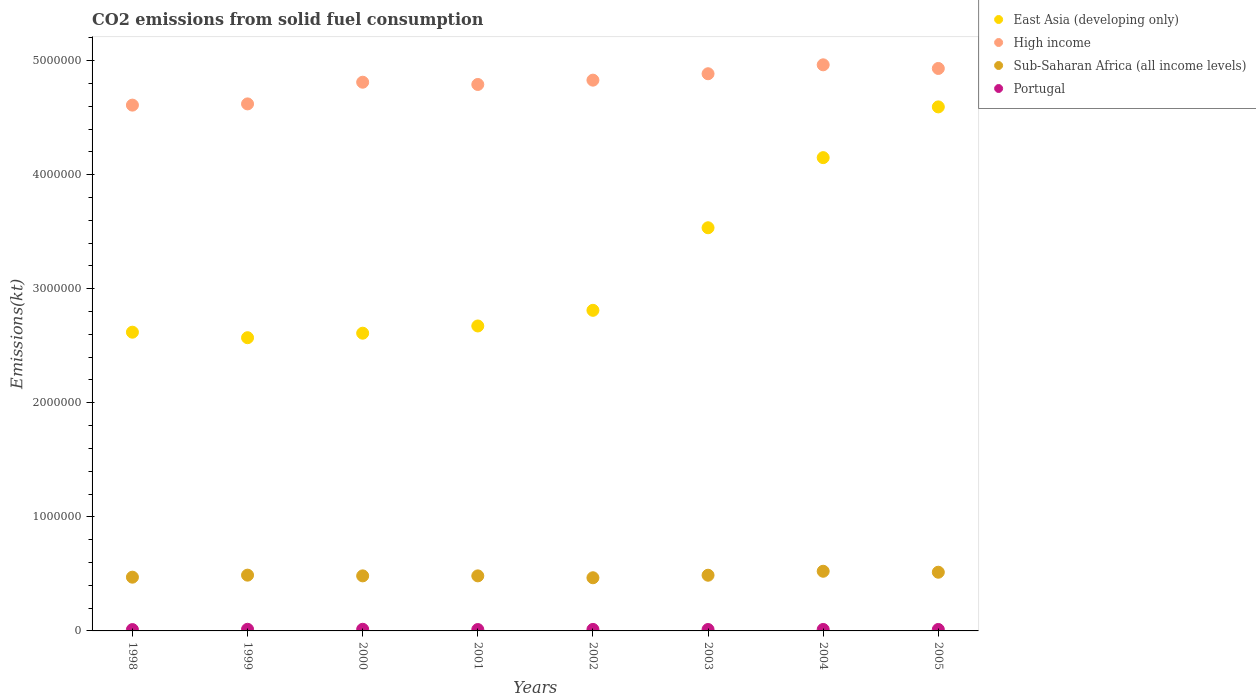How many different coloured dotlines are there?
Your answer should be very brief. 4. What is the amount of CO2 emitted in Portugal in 2005?
Your answer should be very brief. 1.28e+04. Across all years, what is the maximum amount of CO2 emitted in Portugal?
Ensure brevity in your answer.  1.44e+04. Across all years, what is the minimum amount of CO2 emitted in High income?
Your answer should be compact. 4.61e+06. In which year was the amount of CO2 emitted in Sub-Saharan Africa (all income levels) maximum?
Provide a succinct answer. 2004. In which year was the amount of CO2 emitted in Sub-Saharan Africa (all income levels) minimum?
Your answer should be compact. 2002. What is the total amount of CO2 emitted in Portugal in the graph?
Ensure brevity in your answer.  1.04e+05. What is the difference between the amount of CO2 emitted in Portugal in 2000 and that in 2004?
Offer a very short reply. 1477.8. What is the difference between the amount of CO2 emitted in High income in 1999 and the amount of CO2 emitted in East Asia (developing only) in 2000?
Your answer should be very brief. 2.01e+06. What is the average amount of CO2 emitted in East Asia (developing only) per year?
Provide a succinct answer. 3.20e+06. In the year 1998, what is the difference between the amount of CO2 emitted in Portugal and amount of CO2 emitted in Sub-Saharan Africa (all income levels)?
Your answer should be compact. -4.59e+05. What is the ratio of the amount of CO2 emitted in Portugal in 1998 to that in 2004?
Make the answer very short. 0.91. Is the difference between the amount of CO2 emitted in Portugal in 1998 and 2005 greater than the difference between the amount of CO2 emitted in Sub-Saharan Africa (all income levels) in 1998 and 2005?
Your answer should be compact. Yes. What is the difference between the highest and the second highest amount of CO2 emitted in East Asia (developing only)?
Your answer should be compact. 4.45e+05. What is the difference between the highest and the lowest amount of CO2 emitted in East Asia (developing only)?
Your answer should be very brief. 2.02e+06. In how many years, is the amount of CO2 emitted in East Asia (developing only) greater than the average amount of CO2 emitted in East Asia (developing only) taken over all years?
Make the answer very short. 3. Is the sum of the amount of CO2 emitted in East Asia (developing only) in 1998 and 2000 greater than the maximum amount of CO2 emitted in Portugal across all years?
Make the answer very short. Yes. Does the amount of CO2 emitted in Sub-Saharan Africa (all income levels) monotonically increase over the years?
Offer a very short reply. No. How many years are there in the graph?
Ensure brevity in your answer.  8. What is the difference between two consecutive major ticks on the Y-axis?
Keep it short and to the point. 1.00e+06. Does the graph contain grids?
Your answer should be very brief. No. Where does the legend appear in the graph?
Ensure brevity in your answer.  Top right. How are the legend labels stacked?
Your response must be concise. Vertical. What is the title of the graph?
Ensure brevity in your answer.  CO2 emissions from solid fuel consumption. What is the label or title of the X-axis?
Your response must be concise. Years. What is the label or title of the Y-axis?
Make the answer very short. Emissions(kt). What is the Emissions(kt) in East Asia (developing only) in 1998?
Your response must be concise. 2.62e+06. What is the Emissions(kt) in High income in 1998?
Give a very brief answer. 4.61e+06. What is the Emissions(kt) in Sub-Saharan Africa (all income levels) in 1998?
Keep it short and to the point. 4.71e+05. What is the Emissions(kt) of Portugal in 1998?
Offer a very short reply. 1.18e+04. What is the Emissions(kt) of East Asia (developing only) in 1999?
Provide a short and direct response. 2.57e+06. What is the Emissions(kt) in High income in 1999?
Make the answer very short. 4.62e+06. What is the Emissions(kt) of Sub-Saharan Africa (all income levels) in 1999?
Your answer should be very brief. 4.89e+05. What is the Emissions(kt) of Portugal in 1999?
Your answer should be compact. 1.44e+04. What is the Emissions(kt) of East Asia (developing only) in 2000?
Offer a terse response. 2.61e+06. What is the Emissions(kt) of High income in 2000?
Keep it short and to the point. 4.81e+06. What is the Emissions(kt) of Sub-Saharan Africa (all income levels) in 2000?
Provide a succinct answer. 4.83e+05. What is the Emissions(kt) in Portugal in 2000?
Make the answer very short. 1.44e+04. What is the Emissions(kt) in East Asia (developing only) in 2001?
Your answer should be compact. 2.67e+06. What is the Emissions(kt) in High income in 2001?
Ensure brevity in your answer.  4.79e+06. What is the Emissions(kt) of Sub-Saharan Africa (all income levels) in 2001?
Your answer should be compact. 4.83e+05. What is the Emissions(kt) of Portugal in 2001?
Your answer should be very brief. 1.22e+04. What is the Emissions(kt) in East Asia (developing only) in 2002?
Your response must be concise. 2.81e+06. What is the Emissions(kt) in High income in 2002?
Your answer should be very brief. 4.83e+06. What is the Emissions(kt) of Sub-Saharan Africa (all income levels) in 2002?
Keep it short and to the point. 4.66e+05. What is the Emissions(kt) in Portugal in 2002?
Offer a terse response. 1.32e+04. What is the Emissions(kt) in East Asia (developing only) in 2003?
Make the answer very short. 3.53e+06. What is the Emissions(kt) in High income in 2003?
Make the answer very short. 4.88e+06. What is the Emissions(kt) in Sub-Saharan Africa (all income levels) in 2003?
Keep it short and to the point. 4.88e+05. What is the Emissions(kt) in Portugal in 2003?
Provide a short and direct response. 1.24e+04. What is the Emissions(kt) of East Asia (developing only) in 2004?
Give a very brief answer. 4.15e+06. What is the Emissions(kt) of High income in 2004?
Offer a terse response. 4.96e+06. What is the Emissions(kt) in Sub-Saharan Africa (all income levels) in 2004?
Provide a short and direct response. 5.23e+05. What is the Emissions(kt) in Portugal in 2004?
Your answer should be compact. 1.29e+04. What is the Emissions(kt) in East Asia (developing only) in 2005?
Provide a short and direct response. 4.59e+06. What is the Emissions(kt) in High income in 2005?
Keep it short and to the point. 4.93e+06. What is the Emissions(kt) of Sub-Saharan Africa (all income levels) in 2005?
Your response must be concise. 5.15e+05. What is the Emissions(kt) of Portugal in 2005?
Ensure brevity in your answer.  1.28e+04. Across all years, what is the maximum Emissions(kt) in East Asia (developing only)?
Make the answer very short. 4.59e+06. Across all years, what is the maximum Emissions(kt) in High income?
Your response must be concise. 4.96e+06. Across all years, what is the maximum Emissions(kt) of Sub-Saharan Africa (all income levels)?
Provide a short and direct response. 5.23e+05. Across all years, what is the maximum Emissions(kt) in Portugal?
Provide a short and direct response. 1.44e+04. Across all years, what is the minimum Emissions(kt) in East Asia (developing only)?
Provide a succinct answer. 2.57e+06. Across all years, what is the minimum Emissions(kt) of High income?
Give a very brief answer. 4.61e+06. Across all years, what is the minimum Emissions(kt) in Sub-Saharan Africa (all income levels)?
Keep it short and to the point. 4.66e+05. Across all years, what is the minimum Emissions(kt) in Portugal?
Provide a short and direct response. 1.18e+04. What is the total Emissions(kt) of East Asia (developing only) in the graph?
Provide a short and direct response. 2.56e+07. What is the total Emissions(kt) of High income in the graph?
Offer a terse response. 3.84e+07. What is the total Emissions(kt) of Sub-Saharan Africa (all income levels) in the graph?
Keep it short and to the point. 3.92e+06. What is the total Emissions(kt) in Portugal in the graph?
Ensure brevity in your answer.  1.04e+05. What is the difference between the Emissions(kt) in East Asia (developing only) in 1998 and that in 1999?
Your response must be concise. 4.84e+04. What is the difference between the Emissions(kt) of High income in 1998 and that in 1999?
Your response must be concise. -1.08e+04. What is the difference between the Emissions(kt) in Sub-Saharan Africa (all income levels) in 1998 and that in 1999?
Offer a very short reply. -1.78e+04. What is the difference between the Emissions(kt) in Portugal in 1998 and that in 1999?
Your response must be concise. -2603.57. What is the difference between the Emissions(kt) in East Asia (developing only) in 1998 and that in 2000?
Provide a short and direct response. 8834.61. What is the difference between the Emissions(kt) of High income in 1998 and that in 2000?
Provide a succinct answer. -2.01e+05. What is the difference between the Emissions(kt) in Sub-Saharan Africa (all income levels) in 1998 and that in 2000?
Your response must be concise. -1.15e+04. What is the difference between the Emissions(kt) in Portugal in 1998 and that in 2000?
Your answer should be very brief. -2577.9. What is the difference between the Emissions(kt) of East Asia (developing only) in 1998 and that in 2001?
Your answer should be compact. -5.45e+04. What is the difference between the Emissions(kt) of High income in 1998 and that in 2001?
Offer a terse response. -1.81e+05. What is the difference between the Emissions(kt) of Sub-Saharan Africa (all income levels) in 1998 and that in 2001?
Provide a succinct answer. -1.14e+04. What is the difference between the Emissions(kt) of Portugal in 1998 and that in 2001?
Keep it short and to the point. -399.7. What is the difference between the Emissions(kt) in East Asia (developing only) in 1998 and that in 2002?
Offer a very short reply. -1.92e+05. What is the difference between the Emissions(kt) of High income in 1998 and that in 2002?
Provide a short and direct response. -2.19e+05. What is the difference between the Emissions(kt) in Sub-Saharan Africa (all income levels) in 1998 and that in 2002?
Provide a short and direct response. 5099.47. What is the difference between the Emissions(kt) in Portugal in 1998 and that in 2002?
Your answer should be compact. -1397.13. What is the difference between the Emissions(kt) of East Asia (developing only) in 1998 and that in 2003?
Make the answer very short. -9.15e+05. What is the difference between the Emissions(kt) in High income in 1998 and that in 2003?
Your answer should be very brief. -2.75e+05. What is the difference between the Emissions(kt) of Sub-Saharan Africa (all income levels) in 1998 and that in 2003?
Give a very brief answer. -1.71e+04. What is the difference between the Emissions(kt) in Portugal in 1998 and that in 2003?
Offer a terse response. -663.73. What is the difference between the Emissions(kt) in East Asia (developing only) in 1998 and that in 2004?
Offer a terse response. -1.53e+06. What is the difference between the Emissions(kt) in High income in 1998 and that in 2004?
Ensure brevity in your answer.  -3.53e+05. What is the difference between the Emissions(kt) in Sub-Saharan Africa (all income levels) in 1998 and that in 2004?
Give a very brief answer. -5.19e+04. What is the difference between the Emissions(kt) in Portugal in 1998 and that in 2004?
Your answer should be compact. -1100.1. What is the difference between the Emissions(kt) of East Asia (developing only) in 1998 and that in 2005?
Keep it short and to the point. -1.98e+06. What is the difference between the Emissions(kt) in High income in 1998 and that in 2005?
Provide a short and direct response. -3.21e+05. What is the difference between the Emissions(kt) of Sub-Saharan Africa (all income levels) in 1998 and that in 2005?
Keep it short and to the point. -4.34e+04. What is the difference between the Emissions(kt) in Portugal in 1998 and that in 2005?
Ensure brevity in your answer.  -986.42. What is the difference between the Emissions(kt) of East Asia (developing only) in 1999 and that in 2000?
Offer a terse response. -3.96e+04. What is the difference between the Emissions(kt) in High income in 1999 and that in 2000?
Your answer should be very brief. -1.90e+05. What is the difference between the Emissions(kt) in Sub-Saharan Africa (all income levels) in 1999 and that in 2000?
Provide a short and direct response. 6298.44. What is the difference between the Emissions(kt) in Portugal in 1999 and that in 2000?
Offer a terse response. 25.67. What is the difference between the Emissions(kt) in East Asia (developing only) in 1999 and that in 2001?
Give a very brief answer. -1.03e+05. What is the difference between the Emissions(kt) in High income in 1999 and that in 2001?
Give a very brief answer. -1.70e+05. What is the difference between the Emissions(kt) in Sub-Saharan Africa (all income levels) in 1999 and that in 2001?
Provide a short and direct response. 6355.04. What is the difference between the Emissions(kt) in Portugal in 1999 and that in 2001?
Make the answer very short. 2203.87. What is the difference between the Emissions(kt) in East Asia (developing only) in 1999 and that in 2002?
Offer a very short reply. -2.40e+05. What is the difference between the Emissions(kt) in High income in 1999 and that in 2002?
Your answer should be compact. -2.08e+05. What is the difference between the Emissions(kt) in Sub-Saharan Africa (all income levels) in 1999 and that in 2002?
Your answer should be compact. 2.29e+04. What is the difference between the Emissions(kt) of Portugal in 1999 and that in 2002?
Offer a very short reply. 1206.44. What is the difference between the Emissions(kt) of East Asia (developing only) in 1999 and that in 2003?
Your response must be concise. -9.64e+05. What is the difference between the Emissions(kt) in High income in 1999 and that in 2003?
Make the answer very short. -2.64e+05. What is the difference between the Emissions(kt) of Sub-Saharan Africa (all income levels) in 1999 and that in 2003?
Your answer should be compact. 725.29. What is the difference between the Emissions(kt) in Portugal in 1999 and that in 2003?
Keep it short and to the point. 1939.84. What is the difference between the Emissions(kt) in East Asia (developing only) in 1999 and that in 2004?
Your answer should be compact. -1.58e+06. What is the difference between the Emissions(kt) of High income in 1999 and that in 2004?
Keep it short and to the point. -3.43e+05. What is the difference between the Emissions(kt) in Sub-Saharan Africa (all income levels) in 1999 and that in 2004?
Your answer should be very brief. -3.41e+04. What is the difference between the Emissions(kt) of Portugal in 1999 and that in 2004?
Provide a succinct answer. 1503.47. What is the difference between the Emissions(kt) of East Asia (developing only) in 1999 and that in 2005?
Offer a terse response. -2.02e+06. What is the difference between the Emissions(kt) of High income in 1999 and that in 2005?
Your answer should be compact. -3.11e+05. What is the difference between the Emissions(kt) in Sub-Saharan Africa (all income levels) in 1999 and that in 2005?
Give a very brief answer. -2.56e+04. What is the difference between the Emissions(kt) of Portugal in 1999 and that in 2005?
Your answer should be compact. 1617.15. What is the difference between the Emissions(kt) of East Asia (developing only) in 2000 and that in 2001?
Give a very brief answer. -6.34e+04. What is the difference between the Emissions(kt) in High income in 2000 and that in 2001?
Your answer should be compact. 1.97e+04. What is the difference between the Emissions(kt) of Sub-Saharan Africa (all income levels) in 2000 and that in 2001?
Provide a short and direct response. 56.6. What is the difference between the Emissions(kt) in Portugal in 2000 and that in 2001?
Ensure brevity in your answer.  2178.2. What is the difference between the Emissions(kt) in East Asia (developing only) in 2000 and that in 2002?
Your response must be concise. -2.01e+05. What is the difference between the Emissions(kt) of High income in 2000 and that in 2002?
Give a very brief answer. -1.81e+04. What is the difference between the Emissions(kt) of Sub-Saharan Africa (all income levels) in 2000 and that in 2002?
Give a very brief answer. 1.66e+04. What is the difference between the Emissions(kt) in Portugal in 2000 and that in 2002?
Your answer should be compact. 1180.77. What is the difference between the Emissions(kt) of East Asia (developing only) in 2000 and that in 2003?
Provide a succinct answer. -9.24e+05. What is the difference between the Emissions(kt) of High income in 2000 and that in 2003?
Make the answer very short. -7.43e+04. What is the difference between the Emissions(kt) in Sub-Saharan Africa (all income levels) in 2000 and that in 2003?
Make the answer very short. -5573.15. What is the difference between the Emissions(kt) of Portugal in 2000 and that in 2003?
Your response must be concise. 1914.17. What is the difference between the Emissions(kt) of East Asia (developing only) in 2000 and that in 2004?
Make the answer very short. -1.54e+06. What is the difference between the Emissions(kt) of High income in 2000 and that in 2004?
Provide a short and direct response. -1.53e+05. What is the difference between the Emissions(kt) in Sub-Saharan Africa (all income levels) in 2000 and that in 2004?
Provide a short and direct response. -4.04e+04. What is the difference between the Emissions(kt) of Portugal in 2000 and that in 2004?
Your answer should be compact. 1477.8. What is the difference between the Emissions(kt) in East Asia (developing only) in 2000 and that in 2005?
Offer a very short reply. -1.98e+06. What is the difference between the Emissions(kt) of High income in 2000 and that in 2005?
Offer a terse response. -1.21e+05. What is the difference between the Emissions(kt) in Sub-Saharan Africa (all income levels) in 2000 and that in 2005?
Ensure brevity in your answer.  -3.19e+04. What is the difference between the Emissions(kt) of Portugal in 2000 and that in 2005?
Your response must be concise. 1591.48. What is the difference between the Emissions(kt) of East Asia (developing only) in 2001 and that in 2002?
Your response must be concise. -1.37e+05. What is the difference between the Emissions(kt) in High income in 2001 and that in 2002?
Ensure brevity in your answer.  -3.79e+04. What is the difference between the Emissions(kt) of Sub-Saharan Africa (all income levels) in 2001 and that in 2002?
Give a very brief answer. 1.65e+04. What is the difference between the Emissions(kt) in Portugal in 2001 and that in 2002?
Provide a succinct answer. -997.42. What is the difference between the Emissions(kt) in East Asia (developing only) in 2001 and that in 2003?
Offer a terse response. -8.61e+05. What is the difference between the Emissions(kt) in High income in 2001 and that in 2003?
Offer a terse response. -9.40e+04. What is the difference between the Emissions(kt) of Sub-Saharan Africa (all income levels) in 2001 and that in 2003?
Provide a succinct answer. -5629.75. What is the difference between the Emissions(kt) of Portugal in 2001 and that in 2003?
Make the answer very short. -264.02. What is the difference between the Emissions(kt) of East Asia (developing only) in 2001 and that in 2004?
Make the answer very short. -1.48e+06. What is the difference between the Emissions(kt) of High income in 2001 and that in 2004?
Provide a short and direct response. -1.72e+05. What is the difference between the Emissions(kt) in Sub-Saharan Africa (all income levels) in 2001 and that in 2004?
Provide a short and direct response. -4.05e+04. What is the difference between the Emissions(kt) in Portugal in 2001 and that in 2004?
Your response must be concise. -700.4. What is the difference between the Emissions(kt) in East Asia (developing only) in 2001 and that in 2005?
Offer a terse response. -1.92e+06. What is the difference between the Emissions(kt) in High income in 2001 and that in 2005?
Provide a short and direct response. -1.40e+05. What is the difference between the Emissions(kt) of Sub-Saharan Africa (all income levels) in 2001 and that in 2005?
Give a very brief answer. -3.20e+04. What is the difference between the Emissions(kt) in Portugal in 2001 and that in 2005?
Provide a short and direct response. -586.72. What is the difference between the Emissions(kt) in East Asia (developing only) in 2002 and that in 2003?
Provide a succinct answer. -7.24e+05. What is the difference between the Emissions(kt) of High income in 2002 and that in 2003?
Your response must be concise. -5.62e+04. What is the difference between the Emissions(kt) in Sub-Saharan Africa (all income levels) in 2002 and that in 2003?
Your response must be concise. -2.22e+04. What is the difference between the Emissions(kt) in Portugal in 2002 and that in 2003?
Provide a short and direct response. 733.4. What is the difference between the Emissions(kt) in East Asia (developing only) in 2002 and that in 2004?
Make the answer very short. -1.34e+06. What is the difference between the Emissions(kt) in High income in 2002 and that in 2004?
Give a very brief answer. -1.34e+05. What is the difference between the Emissions(kt) in Sub-Saharan Africa (all income levels) in 2002 and that in 2004?
Offer a terse response. -5.70e+04. What is the difference between the Emissions(kt) in Portugal in 2002 and that in 2004?
Ensure brevity in your answer.  297.03. What is the difference between the Emissions(kt) in East Asia (developing only) in 2002 and that in 2005?
Your response must be concise. -1.78e+06. What is the difference between the Emissions(kt) in High income in 2002 and that in 2005?
Offer a terse response. -1.02e+05. What is the difference between the Emissions(kt) in Sub-Saharan Africa (all income levels) in 2002 and that in 2005?
Provide a succinct answer. -4.85e+04. What is the difference between the Emissions(kt) of Portugal in 2002 and that in 2005?
Your answer should be very brief. 410.7. What is the difference between the Emissions(kt) of East Asia (developing only) in 2003 and that in 2004?
Your answer should be compact. -6.15e+05. What is the difference between the Emissions(kt) in High income in 2003 and that in 2004?
Offer a terse response. -7.83e+04. What is the difference between the Emissions(kt) of Sub-Saharan Africa (all income levels) in 2003 and that in 2004?
Provide a succinct answer. -3.48e+04. What is the difference between the Emissions(kt) in Portugal in 2003 and that in 2004?
Your response must be concise. -436.37. What is the difference between the Emissions(kt) in East Asia (developing only) in 2003 and that in 2005?
Offer a very short reply. -1.06e+06. What is the difference between the Emissions(kt) of High income in 2003 and that in 2005?
Keep it short and to the point. -4.63e+04. What is the difference between the Emissions(kt) of Sub-Saharan Africa (all income levels) in 2003 and that in 2005?
Offer a terse response. -2.64e+04. What is the difference between the Emissions(kt) in Portugal in 2003 and that in 2005?
Ensure brevity in your answer.  -322.7. What is the difference between the Emissions(kt) of East Asia (developing only) in 2004 and that in 2005?
Make the answer very short. -4.45e+05. What is the difference between the Emissions(kt) in High income in 2004 and that in 2005?
Your answer should be very brief. 3.20e+04. What is the difference between the Emissions(kt) in Sub-Saharan Africa (all income levels) in 2004 and that in 2005?
Give a very brief answer. 8467.34. What is the difference between the Emissions(kt) in Portugal in 2004 and that in 2005?
Offer a terse response. 113.68. What is the difference between the Emissions(kt) of East Asia (developing only) in 1998 and the Emissions(kt) of High income in 1999?
Make the answer very short. -2.00e+06. What is the difference between the Emissions(kt) in East Asia (developing only) in 1998 and the Emissions(kt) in Sub-Saharan Africa (all income levels) in 1999?
Keep it short and to the point. 2.13e+06. What is the difference between the Emissions(kt) in East Asia (developing only) in 1998 and the Emissions(kt) in Portugal in 1999?
Provide a short and direct response. 2.60e+06. What is the difference between the Emissions(kt) of High income in 1998 and the Emissions(kt) of Sub-Saharan Africa (all income levels) in 1999?
Make the answer very short. 4.12e+06. What is the difference between the Emissions(kt) in High income in 1998 and the Emissions(kt) in Portugal in 1999?
Make the answer very short. 4.60e+06. What is the difference between the Emissions(kt) in Sub-Saharan Africa (all income levels) in 1998 and the Emissions(kt) in Portugal in 1999?
Provide a succinct answer. 4.57e+05. What is the difference between the Emissions(kt) of East Asia (developing only) in 1998 and the Emissions(kt) of High income in 2000?
Your response must be concise. -2.19e+06. What is the difference between the Emissions(kt) in East Asia (developing only) in 1998 and the Emissions(kt) in Sub-Saharan Africa (all income levels) in 2000?
Offer a very short reply. 2.14e+06. What is the difference between the Emissions(kt) in East Asia (developing only) in 1998 and the Emissions(kt) in Portugal in 2000?
Offer a terse response. 2.60e+06. What is the difference between the Emissions(kt) of High income in 1998 and the Emissions(kt) of Sub-Saharan Africa (all income levels) in 2000?
Your answer should be compact. 4.13e+06. What is the difference between the Emissions(kt) in High income in 1998 and the Emissions(kt) in Portugal in 2000?
Make the answer very short. 4.60e+06. What is the difference between the Emissions(kt) in Sub-Saharan Africa (all income levels) in 1998 and the Emissions(kt) in Portugal in 2000?
Make the answer very short. 4.57e+05. What is the difference between the Emissions(kt) of East Asia (developing only) in 1998 and the Emissions(kt) of High income in 2001?
Make the answer very short. -2.17e+06. What is the difference between the Emissions(kt) in East Asia (developing only) in 1998 and the Emissions(kt) in Sub-Saharan Africa (all income levels) in 2001?
Your response must be concise. 2.14e+06. What is the difference between the Emissions(kt) in East Asia (developing only) in 1998 and the Emissions(kt) in Portugal in 2001?
Offer a very short reply. 2.61e+06. What is the difference between the Emissions(kt) of High income in 1998 and the Emissions(kt) of Sub-Saharan Africa (all income levels) in 2001?
Your response must be concise. 4.13e+06. What is the difference between the Emissions(kt) in High income in 1998 and the Emissions(kt) in Portugal in 2001?
Provide a short and direct response. 4.60e+06. What is the difference between the Emissions(kt) of Sub-Saharan Africa (all income levels) in 1998 and the Emissions(kt) of Portugal in 2001?
Provide a succinct answer. 4.59e+05. What is the difference between the Emissions(kt) in East Asia (developing only) in 1998 and the Emissions(kt) in High income in 2002?
Provide a short and direct response. -2.21e+06. What is the difference between the Emissions(kt) in East Asia (developing only) in 1998 and the Emissions(kt) in Sub-Saharan Africa (all income levels) in 2002?
Provide a short and direct response. 2.15e+06. What is the difference between the Emissions(kt) in East Asia (developing only) in 1998 and the Emissions(kt) in Portugal in 2002?
Offer a very short reply. 2.61e+06. What is the difference between the Emissions(kt) of High income in 1998 and the Emissions(kt) of Sub-Saharan Africa (all income levels) in 2002?
Provide a short and direct response. 4.14e+06. What is the difference between the Emissions(kt) of High income in 1998 and the Emissions(kt) of Portugal in 2002?
Your answer should be compact. 4.60e+06. What is the difference between the Emissions(kt) of Sub-Saharan Africa (all income levels) in 1998 and the Emissions(kt) of Portugal in 2002?
Provide a succinct answer. 4.58e+05. What is the difference between the Emissions(kt) in East Asia (developing only) in 1998 and the Emissions(kt) in High income in 2003?
Your answer should be very brief. -2.27e+06. What is the difference between the Emissions(kt) in East Asia (developing only) in 1998 and the Emissions(kt) in Sub-Saharan Africa (all income levels) in 2003?
Give a very brief answer. 2.13e+06. What is the difference between the Emissions(kt) of East Asia (developing only) in 1998 and the Emissions(kt) of Portugal in 2003?
Your answer should be compact. 2.61e+06. What is the difference between the Emissions(kt) in High income in 1998 and the Emissions(kt) in Sub-Saharan Africa (all income levels) in 2003?
Your answer should be very brief. 4.12e+06. What is the difference between the Emissions(kt) of High income in 1998 and the Emissions(kt) of Portugal in 2003?
Make the answer very short. 4.60e+06. What is the difference between the Emissions(kt) of Sub-Saharan Africa (all income levels) in 1998 and the Emissions(kt) of Portugal in 2003?
Give a very brief answer. 4.59e+05. What is the difference between the Emissions(kt) in East Asia (developing only) in 1998 and the Emissions(kt) in High income in 2004?
Provide a short and direct response. -2.34e+06. What is the difference between the Emissions(kt) in East Asia (developing only) in 1998 and the Emissions(kt) in Sub-Saharan Africa (all income levels) in 2004?
Provide a short and direct response. 2.10e+06. What is the difference between the Emissions(kt) of East Asia (developing only) in 1998 and the Emissions(kt) of Portugal in 2004?
Make the answer very short. 2.61e+06. What is the difference between the Emissions(kt) in High income in 1998 and the Emissions(kt) in Sub-Saharan Africa (all income levels) in 2004?
Make the answer very short. 4.09e+06. What is the difference between the Emissions(kt) in High income in 1998 and the Emissions(kt) in Portugal in 2004?
Give a very brief answer. 4.60e+06. What is the difference between the Emissions(kt) of Sub-Saharan Africa (all income levels) in 1998 and the Emissions(kt) of Portugal in 2004?
Your response must be concise. 4.58e+05. What is the difference between the Emissions(kt) in East Asia (developing only) in 1998 and the Emissions(kt) in High income in 2005?
Keep it short and to the point. -2.31e+06. What is the difference between the Emissions(kt) in East Asia (developing only) in 1998 and the Emissions(kt) in Sub-Saharan Africa (all income levels) in 2005?
Your answer should be compact. 2.10e+06. What is the difference between the Emissions(kt) of East Asia (developing only) in 1998 and the Emissions(kt) of Portugal in 2005?
Give a very brief answer. 2.61e+06. What is the difference between the Emissions(kt) of High income in 1998 and the Emissions(kt) of Sub-Saharan Africa (all income levels) in 2005?
Offer a terse response. 4.09e+06. What is the difference between the Emissions(kt) of High income in 1998 and the Emissions(kt) of Portugal in 2005?
Give a very brief answer. 4.60e+06. What is the difference between the Emissions(kt) in Sub-Saharan Africa (all income levels) in 1998 and the Emissions(kt) in Portugal in 2005?
Your response must be concise. 4.58e+05. What is the difference between the Emissions(kt) in East Asia (developing only) in 1999 and the Emissions(kt) in High income in 2000?
Your answer should be very brief. -2.24e+06. What is the difference between the Emissions(kt) in East Asia (developing only) in 1999 and the Emissions(kt) in Sub-Saharan Africa (all income levels) in 2000?
Your response must be concise. 2.09e+06. What is the difference between the Emissions(kt) in East Asia (developing only) in 1999 and the Emissions(kt) in Portugal in 2000?
Give a very brief answer. 2.56e+06. What is the difference between the Emissions(kt) of High income in 1999 and the Emissions(kt) of Sub-Saharan Africa (all income levels) in 2000?
Offer a very short reply. 4.14e+06. What is the difference between the Emissions(kt) of High income in 1999 and the Emissions(kt) of Portugal in 2000?
Give a very brief answer. 4.61e+06. What is the difference between the Emissions(kt) in Sub-Saharan Africa (all income levels) in 1999 and the Emissions(kt) in Portugal in 2000?
Ensure brevity in your answer.  4.75e+05. What is the difference between the Emissions(kt) of East Asia (developing only) in 1999 and the Emissions(kt) of High income in 2001?
Your response must be concise. -2.22e+06. What is the difference between the Emissions(kt) in East Asia (developing only) in 1999 and the Emissions(kt) in Sub-Saharan Africa (all income levels) in 2001?
Offer a very short reply. 2.09e+06. What is the difference between the Emissions(kt) of East Asia (developing only) in 1999 and the Emissions(kt) of Portugal in 2001?
Make the answer very short. 2.56e+06. What is the difference between the Emissions(kt) in High income in 1999 and the Emissions(kt) in Sub-Saharan Africa (all income levels) in 2001?
Your response must be concise. 4.14e+06. What is the difference between the Emissions(kt) in High income in 1999 and the Emissions(kt) in Portugal in 2001?
Keep it short and to the point. 4.61e+06. What is the difference between the Emissions(kt) in Sub-Saharan Africa (all income levels) in 1999 and the Emissions(kt) in Portugal in 2001?
Offer a terse response. 4.77e+05. What is the difference between the Emissions(kt) of East Asia (developing only) in 1999 and the Emissions(kt) of High income in 2002?
Provide a short and direct response. -2.26e+06. What is the difference between the Emissions(kt) in East Asia (developing only) in 1999 and the Emissions(kt) in Sub-Saharan Africa (all income levels) in 2002?
Your answer should be very brief. 2.10e+06. What is the difference between the Emissions(kt) of East Asia (developing only) in 1999 and the Emissions(kt) of Portugal in 2002?
Offer a very short reply. 2.56e+06. What is the difference between the Emissions(kt) of High income in 1999 and the Emissions(kt) of Sub-Saharan Africa (all income levels) in 2002?
Keep it short and to the point. 4.15e+06. What is the difference between the Emissions(kt) of High income in 1999 and the Emissions(kt) of Portugal in 2002?
Provide a succinct answer. 4.61e+06. What is the difference between the Emissions(kt) in Sub-Saharan Africa (all income levels) in 1999 and the Emissions(kt) in Portugal in 2002?
Ensure brevity in your answer.  4.76e+05. What is the difference between the Emissions(kt) in East Asia (developing only) in 1999 and the Emissions(kt) in High income in 2003?
Make the answer very short. -2.31e+06. What is the difference between the Emissions(kt) in East Asia (developing only) in 1999 and the Emissions(kt) in Sub-Saharan Africa (all income levels) in 2003?
Your answer should be compact. 2.08e+06. What is the difference between the Emissions(kt) in East Asia (developing only) in 1999 and the Emissions(kt) in Portugal in 2003?
Offer a terse response. 2.56e+06. What is the difference between the Emissions(kt) of High income in 1999 and the Emissions(kt) of Sub-Saharan Africa (all income levels) in 2003?
Your answer should be compact. 4.13e+06. What is the difference between the Emissions(kt) in High income in 1999 and the Emissions(kt) in Portugal in 2003?
Provide a short and direct response. 4.61e+06. What is the difference between the Emissions(kt) of Sub-Saharan Africa (all income levels) in 1999 and the Emissions(kt) of Portugal in 2003?
Provide a short and direct response. 4.77e+05. What is the difference between the Emissions(kt) in East Asia (developing only) in 1999 and the Emissions(kt) in High income in 2004?
Provide a succinct answer. -2.39e+06. What is the difference between the Emissions(kt) in East Asia (developing only) in 1999 and the Emissions(kt) in Sub-Saharan Africa (all income levels) in 2004?
Your answer should be compact. 2.05e+06. What is the difference between the Emissions(kt) of East Asia (developing only) in 1999 and the Emissions(kt) of Portugal in 2004?
Give a very brief answer. 2.56e+06. What is the difference between the Emissions(kt) in High income in 1999 and the Emissions(kt) in Sub-Saharan Africa (all income levels) in 2004?
Keep it short and to the point. 4.10e+06. What is the difference between the Emissions(kt) in High income in 1999 and the Emissions(kt) in Portugal in 2004?
Your answer should be compact. 4.61e+06. What is the difference between the Emissions(kt) of Sub-Saharan Africa (all income levels) in 1999 and the Emissions(kt) of Portugal in 2004?
Provide a short and direct response. 4.76e+05. What is the difference between the Emissions(kt) in East Asia (developing only) in 1999 and the Emissions(kt) in High income in 2005?
Provide a short and direct response. -2.36e+06. What is the difference between the Emissions(kt) of East Asia (developing only) in 1999 and the Emissions(kt) of Sub-Saharan Africa (all income levels) in 2005?
Offer a terse response. 2.06e+06. What is the difference between the Emissions(kt) of East Asia (developing only) in 1999 and the Emissions(kt) of Portugal in 2005?
Your response must be concise. 2.56e+06. What is the difference between the Emissions(kt) of High income in 1999 and the Emissions(kt) of Sub-Saharan Africa (all income levels) in 2005?
Your response must be concise. 4.11e+06. What is the difference between the Emissions(kt) of High income in 1999 and the Emissions(kt) of Portugal in 2005?
Your answer should be compact. 4.61e+06. What is the difference between the Emissions(kt) in Sub-Saharan Africa (all income levels) in 1999 and the Emissions(kt) in Portugal in 2005?
Ensure brevity in your answer.  4.76e+05. What is the difference between the Emissions(kt) of East Asia (developing only) in 2000 and the Emissions(kt) of High income in 2001?
Keep it short and to the point. -2.18e+06. What is the difference between the Emissions(kt) of East Asia (developing only) in 2000 and the Emissions(kt) of Sub-Saharan Africa (all income levels) in 2001?
Offer a terse response. 2.13e+06. What is the difference between the Emissions(kt) of East Asia (developing only) in 2000 and the Emissions(kt) of Portugal in 2001?
Ensure brevity in your answer.  2.60e+06. What is the difference between the Emissions(kt) of High income in 2000 and the Emissions(kt) of Sub-Saharan Africa (all income levels) in 2001?
Offer a terse response. 4.33e+06. What is the difference between the Emissions(kt) in High income in 2000 and the Emissions(kt) in Portugal in 2001?
Keep it short and to the point. 4.80e+06. What is the difference between the Emissions(kt) of Sub-Saharan Africa (all income levels) in 2000 and the Emissions(kt) of Portugal in 2001?
Your answer should be very brief. 4.70e+05. What is the difference between the Emissions(kt) of East Asia (developing only) in 2000 and the Emissions(kt) of High income in 2002?
Provide a succinct answer. -2.22e+06. What is the difference between the Emissions(kt) of East Asia (developing only) in 2000 and the Emissions(kt) of Sub-Saharan Africa (all income levels) in 2002?
Offer a terse response. 2.14e+06. What is the difference between the Emissions(kt) in East Asia (developing only) in 2000 and the Emissions(kt) in Portugal in 2002?
Offer a terse response. 2.60e+06. What is the difference between the Emissions(kt) of High income in 2000 and the Emissions(kt) of Sub-Saharan Africa (all income levels) in 2002?
Provide a succinct answer. 4.34e+06. What is the difference between the Emissions(kt) of High income in 2000 and the Emissions(kt) of Portugal in 2002?
Keep it short and to the point. 4.80e+06. What is the difference between the Emissions(kt) in Sub-Saharan Africa (all income levels) in 2000 and the Emissions(kt) in Portugal in 2002?
Offer a very short reply. 4.69e+05. What is the difference between the Emissions(kt) in East Asia (developing only) in 2000 and the Emissions(kt) in High income in 2003?
Make the answer very short. -2.27e+06. What is the difference between the Emissions(kt) of East Asia (developing only) in 2000 and the Emissions(kt) of Sub-Saharan Africa (all income levels) in 2003?
Keep it short and to the point. 2.12e+06. What is the difference between the Emissions(kt) in East Asia (developing only) in 2000 and the Emissions(kt) in Portugal in 2003?
Make the answer very short. 2.60e+06. What is the difference between the Emissions(kt) of High income in 2000 and the Emissions(kt) of Sub-Saharan Africa (all income levels) in 2003?
Give a very brief answer. 4.32e+06. What is the difference between the Emissions(kt) of High income in 2000 and the Emissions(kt) of Portugal in 2003?
Provide a succinct answer. 4.80e+06. What is the difference between the Emissions(kt) of Sub-Saharan Africa (all income levels) in 2000 and the Emissions(kt) of Portugal in 2003?
Offer a very short reply. 4.70e+05. What is the difference between the Emissions(kt) in East Asia (developing only) in 2000 and the Emissions(kt) in High income in 2004?
Keep it short and to the point. -2.35e+06. What is the difference between the Emissions(kt) of East Asia (developing only) in 2000 and the Emissions(kt) of Sub-Saharan Africa (all income levels) in 2004?
Make the answer very short. 2.09e+06. What is the difference between the Emissions(kt) of East Asia (developing only) in 2000 and the Emissions(kt) of Portugal in 2004?
Ensure brevity in your answer.  2.60e+06. What is the difference between the Emissions(kt) of High income in 2000 and the Emissions(kt) of Sub-Saharan Africa (all income levels) in 2004?
Keep it short and to the point. 4.29e+06. What is the difference between the Emissions(kt) of High income in 2000 and the Emissions(kt) of Portugal in 2004?
Keep it short and to the point. 4.80e+06. What is the difference between the Emissions(kt) of Sub-Saharan Africa (all income levels) in 2000 and the Emissions(kt) of Portugal in 2004?
Provide a succinct answer. 4.70e+05. What is the difference between the Emissions(kt) in East Asia (developing only) in 2000 and the Emissions(kt) in High income in 2005?
Offer a very short reply. -2.32e+06. What is the difference between the Emissions(kt) in East Asia (developing only) in 2000 and the Emissions(kt) in Sub-Saharan Africa (all income levels) in 2005?
Your answer should be very brief. 2.10e+06. What is the difference between the Emissions(kt) of East Asia (developing only) in 2000 and the Emissions(kt) of Portugal in 2005?
Give a very brief answer. 2.60e+06. What is the difference between the Emissions(kt) of High income in 2000 and the Emissions(kt) of Sub-Saharan Africa (all income levels) in 2005?
Make the answer very short. 4.30e+06. What is the difference between the Emissions(kt) in High income in 2000 and the Emissions(kt) in Portugal in 2005?
Ensure brevity in your answer.  4.80e+06. What is the difference between the Emissions(kt) of Sub-Saharan Africa (all income levels) in 2000 and the Emissions(kt) of Portugal in 2005?
Provide a succinct answer. 4.70e+05. What is the difference between the Emissions(kt) of East Asia (developing only) in 2001 and the Emissions(kt) of High income in 2002?
Give a very brief answer. -2.15e+06. What is the difference between the Emissions(kt) in East Asia (developing only) in 2001 and the Emissions(kt) in Sub-Saharan Africa (all income levels) in 2002?
Make the answer very short. 2.21e+06. What is the difference between the Emissions(kt) in East Asia (developing only) in 2001 and the Emissions(kt) in Portugal in 2002?
Your response must be concise. 2.66e+06. What is the difference between the Emissions(kt) in High income in 2001 and the Emissions(kt) in Sub-Saharan Africa (all income levels) in 2002?
Ensure brevity in your answer.  4.32e+06. What is the difference between the Emissions(kt) in High income in 2001 and the Emissions(kt) in Portugal in 2002?
Provide a succinct answer. 4.78e+06. What is the difference between the Emissions(kt) of Sub-Saharan Africa (all income levels) in 2001 and the Emissions(kt) of Portugal in 2002?
Your answer should be very brief. 4.69e+05. What is the difference between the Emissions(kt) of East Asia (developing only) in 2001 and the Emissions(kt) of High income in 2003?
Ensure brevity in your answer.  -2.21e+06. What is the difference between the Emissions(kt) in East Asia (developing only) in 2001 and the Emissions(kt) in Sub-Saharan Africa (all income levels) in 2003?
Ensure brevity in your answer.  2.19e+06. What is the difference between the Emissions(kt) in East Asia (developing only) in 2001 and the Emissions(kt) in Portugal in 2003?
Your answer should be compact. 2.66e+06. What is the difference between the Emissions(kt) in High income in 2001 and the Emissions(kt) in Sub-Saharan Africa (all income levels) in 2003?
Give a very brief answer. 4.30e+06. What is the difference between the Emissions(kt) of High income in 2001 and the Emissions(kt) of Portugal in 2003?
Ensure brevity in your answer.  4.78e+06. What is the difference between the Emissions(kt) in Sub-Saharan Africa (all income levels) in 2001 and the Emissions(kt) in Portugal in 2003?
Your answer should be compact. 4.70e+05. What is the difference between the Emissions(kt) of East Asia (developing only) in 2001 and the Emissions(kt) of High income in 2004?
Your answer should be very brief. -2.29e+06. What is the difference between the Emissions(kt) in East Asia (developing only) in 2001 and the Emissions(kt) in Sub-Saharan Africa (all income levels) in 2004?
Ensure brevity in your answer.  2.15e+06. What is the difference between the Emissions(kt) of East Asia (developing only) in 2001 and the Emissions(kt) of Portugal in 2004?
Provide a short and direct response. 2.66e+06. What is the difference between the Emissions(kt) in High income in 2001 and the Emissions(kt) in Sub-Saharan Africa (all income levels) in 2004?
Your answer should be very brief. 4.27e+06. What is the difference between the Emissions(kt) in High income in 2001 and the Emissions(kt) in Portugal in 2004?
Give a very brief answer. 4.78e+06. What is the difference between the Emissions(kt) in Sub-Saharan Africa (all income levels) in 2001 and the Emissions(kt) in Portugal in 2004?
Your answer should be very brief. 4.70e+05. What is the difference between the Emissions(kt) of East Asia (developing only) in 2001 and the Emissions(kt) of High income in 2005?
Offer a terse response. -2.26e+06. What is the difference between the Emissions(kt) in East Asia (developing only) in 2001 and the Emissions(kt) in Sub-Saharan Africa (all income levels) in 2005?
Offer a very short reply. 2.16e+06. What is the difference between the Emissions(kt) of East Asia (developing only) in 2001 and the Emissions(kt) of Portugal in 2005?
Keep it short and to the point. 2.66e+06. What is the difference between the Emissions(kt) in High income in 2001 and the Emissions(kt) in Sub-Saharan Africa (all income levels) in 2005?
Keep it short and to the point. 4.28e+06. What is the difference between the Emissions(kt) in High income in 2001 and the Emissions(kt) in Portugal in 2005?
Your response must be concise. 4.78e+06. What is the difference between the Emissions(kt) in Sub-Saharan Africa (all income levels) in 2001 and the Emissions(kt) in Portugal in 2005?
Provide a short and direct response. 4.70e+05. What is the difference between the Emissions(kt) of East Asia (developing only) in 2002 and the Emissions(kt) of High income in 2003?
Ensure brevity in your answer.  -2.07e+06. What is the difference between the Emissions(kt) in East Asia (developing only) in 2002 and the Emissions(kt) in Sub-Saharan Africa (all income levels) in 2003?
Offer a terse response. 2.32e+06. What is the difference between the Emissions(kt) in East Asia (developing only) in 2002 and the Emissions(kt) in Portugal in 2003?
Provide a short and direct response. 2.80e+06. What is the difference between the Emissions(kt) in High income in 2002 and the Emissions(kt) in Sub-Saharan Africa (all income levels) in 2003?
Ensure brevity in your answer.  4.34e+06. What is the difference between the Emissions(kt) in High income in 2002 and the Emissions(kt) in Portugal in 2003?
Your response must be concise. 4.82e+06. What is the difference between the Emissions(kt) of Sub-Saharan Africa (all income levels) in 2002 and the Emissions(kt) of Portugal in 2003?
Your answer should be compact. 4.54e+05. What is the difference between the Emissions(kt) of East Asia (developing only) in 2002 and the Emissions(kt) of High income in 2004?
Offer a terse response. -2.15e+06. What is the difference between the Emissions(kt) of East Asia (developing only) in 2002 and the Emissions(kt) of Sub-Saharan Africa (all income levels) in 2004?
Your response must be concise. 2.29e+06. What is the difference between the Emissions(kt) of East Asia (developing only) in 2002 and the Emissions(kt) of Portugal in 2004?
Your answer should be compact. 2.80e+06. What is the difference between the Emissions(kt) in High income in 2002 and the Emissions(kt) in Sub-Saharan Africa (all income levels) in 2004?
Provide a succinct answer. 4.31e+06. What is the difference between the Emissions(kt) in High income in 2002 and the Emissions(kt) in Portugal in 2004?
Your answer should be compact. 4.82e+06. What is the difference between the Emissions(kt) of Sub-Saharan Africa (all income levels) in 2002 and the Emissions(kt) of Portugal in 2004?
Your response must be concise. 4.53e+05. What is the difference between the Emissions(kt) of East Asia (developing only) in 2002 and the Emissions(kt) of High income in 2005?
Make the answer very short. -2.12e+06. What is the difference between the Emissions(kt) of East Asia (developing only) in 2002 and the Emissions(kt) of Sub-Saharan Africa (all income levels) in 2005?
Your answer should be very brief. 2.30e+06. What is the difference between the Emissions(kt) in East Asia (developing only) in 2002 and the Emissions(kt) in Portugal in 2005?
Make the answer very short. 2.80e+06. What is the difference between the Emissions(kt) of High income in 2002 and the Emissions(kt) of Sub-Saharan Africa (all income levels) in 2005?
Ensure brevity in your answer.  4.31e+06. What is the difference between the Emissions(kt) in High income in 2002 and the Emissions(kt) in Portugal in 2005?
Your response must be concise. 4.82e+06. What is the difference between the Emissions(kt) in Sub-Saharan Africa (all income levels) in 2002 and the Emissions(kt) in Portugal in 2005?
Make the answer very short. 4.53e+05. What is the difference between the Emissions(kt) in East Asia (developing only) in 2003 and the Emissions(kt) in High income in 2004?
Your answer should be very brief. -1.43e+06. What is the difference between the Emissions(kt) of East Asia (developing only) in 2003 and the Emissions(kt) of Sub-Saharan Africa (all income levels) in 2004?
Make the answer very short. 3.01e+06. What is the difference between the Emissions(kt) in East Asia (developing only) in 2003 and the Emissions(kt) in Portugal in 2004?
Offer a very short reply. 3.52e+06. What is the difference between the Emissions(kt) in High income in 2003 and the Emissions(kt) in Sub-Saharan Africa (all income levels) in 2004?
Make the answer very short. 4.36e+06. What is the difference between the Emissions(kt) in High income in 2003 and the Emissions(kt) in Portugal in 2004?
Make the answer very short. 4.87e+06. What is the difference between the Emissions(kt) of Sub-Saharan Africa (all income levels) in 2003 and the Emissions(kt) of Portugal in 2004?
Make the answer very short. 4.75e+05. What is the difference between the Emissions(kt) in East Asia (developing only) in 2003 and the Emissions(kt) in High income in 2005?
Your answer should be compact. -1.40e+06. What is the difference between the Emissions(kt) in East Asia (developing only) in 2003 and the Emissions(kt) in Sub-Saharan Africa (all income levels) in 2005?
Provide a short and direct response. 3.02e+06. What is the difference between the Emissions(kt) of East Asia (developing only) in 2003 and the Emissions(kt) of Portugal in 2005?
Make the answer very short. 3.52e+06. What is the difference between the Emissions(kt) of High income in 2003 and the Emissions(kt) of Sub-Saharan Africa (all income levels) in 2005?
Your response must be concise. 4.37e+06. What is the difference between the Emissions(kt) of High income in 2003 and the Emissions(kt) of Portugal in 2005?
Provide a succinct answer. 4.87e+06. What is the difference between the Emissions(kt) in Sub-Saharan Africa (all income levels) in 2003 and the Emissions(kt) in Portugal in 2005?
Your answer should be compact. 4.75e+05. What is the difference between the Emissions(kt) of East Asia (developing only) in 2004 and the Emissions(kt) of High income in 2005?
Make the answer very short. -7.82e+05. What is the difference between the Emissions(kt) of East Asia (developing only) in 2004 and the Emissions(kt) of Sub-Saharan Africa (all income levels) in 2005?
Provide a succinct answer. 3.63e+06. What is the difference between the Emissions(kt) in East Asia (developing only) in 2004 and the Emissions(kt) in Portugal in 2005?
Provide a succinct answer. 4.14e+06. What is the difference between the Emissions(kt) of High income in 2004 and the Emissions(kt) of Sub-Saharan Africa (all income levels) in 2005?
Keep it short and to the point. 4.45e+06. What is the difference between the Emissions(kt) in High income in 2004 and the Emissions(kt) in Portugal in 2005?
Provide a succinct answer. 4.95e+06. What is the difference between the Emissions(kt) in Sub-Saharan Africa (all income levels) in 2004 and the Emissions(kt) in Portugal in 2005?
Offer a very short reply. 5.10e+05. What is the average Emissions(kt) of East Asia (developing only) per year?
Provide a short and direct response. 3.20e+06. What is the average Emissions(kt) in High income per year?
Offer a very short reply. 4.80e+06. What is the average Emissions(kt) in Sub-Saharan Africa (all income levels) per year?
Your answer should be very brief. 4.90e+05. What is the average Emissions(kt) of Portugal per year?
Offer a terse response. 1.30e+04. In the year 1998, what is the difference between the Emissions(kt) of East Asia (developing only) and Emissions(kt) of High income?
Offer a very short reply. -1.99e+06. In the year 1998, what is the difference between the Emissions(kt) of East Asia (developing only) and Emissions(kt) of Sub-Saharan Africa (all income levels)?
Provide a short and direct response. 2.15e+06. In the year 1998, what is the difference between the Emissions(kt) of East Asia (developing only) and Emissions(kt) of Portugal?
Ensure brevity in your answer.  2.61e+06. In the year 1998, what is the difference between the Emissions(kt) of High income and Emissions(kt) of Sub-Saharan Africa (all income levels)?
Make the answer very short. 4.14e+06. In the year 1998, what is the difference between the Emissions(kt) in High income and Emissions(kt) in Portugal?
Ensure brevity in your answer.  4.60e+06. In the year 1998, what is the difference between the Emissions(kt) of Sub-Saharan Africa (all income levels) and Emissions(kt) of Portugal?
Provide a succinct answer. 4.59e+05. In the year 1999, what is the difference between the Emissions(kt) in East Asia (developing only) and Emissions(kt) in High income?
Ensure brevity in your answer.  -2.05e+06. In the year 1999, what is the difference between the Emissions(kt) of East Asia (developing only) and Emissions(kt) of Sub-Saharan Africa (all income levels)?
Keep it short and to the point. 2.08e+06. In the year 1999, what is the difference between the Emissions(kt) in East Asia (developing only) and Emissions(kt) in Portugal?
Give a very brief answer. 2.56e+06. In the year 1999, what is the difference between the Emissions(kt) of High income and Emissions(kt) of Sub-Saharan Africa (all income levels)?
Provide a succinct answer. 4.13e+06. In the year 1999, what is the difference between the Emissions(kt) in High income and Emissions(kt) in Portugal?
Keep it short and to the point. 4.61e+06. In the year 1999, what is the difference between the Emissions(kt) of Sub-Saharan Africa (all income levels) and Emissions(kt) of Portugal?
Make the answer very short. 4.75e+05. In the year 2000, what is the difference between the Emissions(kt) in East Asia (developing only) and Emissions(kt) in High income?
Your answer should be very brief. -2.20e+06. In the year 2000, what is the difference between the Emissions(kt) of East Asia (developing only) and Emissions(kt) of Sub-Saharan Africa (all income levels)?
Provide a short and direct response. 2.13e+06. In the year 2000, what is the difference between the Emissions(kt) of East Asia (developing only) and Emissions(kt) of Portugal?
Your answer should be compact. 2.60e+06. In the year 2000, what is the difference between the Emissions(kt) in High income and Emissions(kt) in Sub-Saharan Africa (all income levels)?
Your answer should be very brief. 4.33e+06. In the year 2000, what is the difference between the Emissions(kt) of High income and Emissions(kt) of Portugal?
Make the answer very short. 4.80e+06. In the year 2000, what is the difference between the Emissions(kt) in Sub-Saharan Africa (all income levels) and Emissions(kt) in Portugal?
Your response must be concise. 4.68e+05. In the year 2001, what is the difference between the Emissions(kt) of East Asia (developing only) and Emissions(kt) of High income?
Your response must be concise. -2.12e+06. In the year 2001, what is the difference between the Emissions(kt) in East Asia (developing only) and Emissions(kt) in Sub-Saharan Africa (all income levels)?
Your answer should be compact. 2.19e+06. In the year 2001, what is the difference between the Emissions(kt) in East Asia (developing only) and Emissions(kt) in Portugal?
Ensure brevity in your answer.  2.66e+06. In the year 2001, what is the difference between the Emissions(kt) in High income and Emissions(kt) in Sub-Saharan Africa (all income levels)?
Keep it short and to the point. 4.31e+06. In the year 2001, what is the difference between the Emissions(kt) of High income and Emissions(kt) of Portugal?
Make the answer very short. 4.78e+06. In the year 2001, what is the difference between the Emissions(kt) in Sub-Saharan Africa (all income levels) and Emissions(kt) in Portugal?
Provide a succinct answer. 4.70e+05. In the year 2002, what is the difference between the Emissions(kt) in East Asia (developing only) and Emissions(kt) in High income?
Give a very brief answer. -2.02e+06. In the year 2002, what is the difference between the Emissions(kt) of East Asia (developing only) and Emissions(kt) of Sub-Saharan Africa (all income levels)?
Offer a terse response. 2.34e+06. In the year 2002, what is the difference between the Emissions(kt) of East Asia (developing only) and Emissions(kt) of Portugal?
Provide a short and direct response. 2.80e+06. In the year 2002, what is the difference between the Emissions(kt) in High income and Emissions(kt) in Sub-Saharan Africa (all income levels)?
Keep it short and to the point. 4.36e+06. In the year 2002, what is the difference between the Emissions(kt) of High income and Emissions(kt) of Portugal?
Provide a short and direct response. 4.82e+06. In the year 2002, what is the difference between the Emissions(kt) in Sub-Saharan Africa (all income levels) and Emissions(kt) in Portugal?
Your response must be concise. 4.53e+05. In the year 2003, what is the difference between the Emissions(kt) of East Asia (developing only) and Emissions(kt) of High income?
Your response must be concise. -1.35e+06. In the year 2003, what is the difference between the Emissions(kt) in East Asia (developing only) and Emissions(kt) in Sub-Saharan Africa (all income levels)?
Keep it short and to the point. 3.05e+06. In the year 2003, what is the difference between the Emissions(kt) of East Asia (developing only) and Emissions(kt) of Portugal?
Provide a short and direct response. 3.52e+06. In the year 2003, what is the difference between the Emissions(kt) of High income and Emissions(kt) of Sub-Saharan Africa (all income levels)?
Your answer should be very brief. 4.40e+06. In the year 2003, what is the difference between the Emissions(kt) of High income and Emissions(kt) of Portugal?
Keep it short and to the point. 4.87e+06. In the year 2003, what is the difference between the Emissions(kt) in Sub-Saharan Africa (all income levels) and Emissions(kt) in Portugal?
Your response must be concise. 4.76e+05. In the year 2004, what is the difference between the Emissions(kt) in East Asia (developing only) and Emissions(kt) in High income?
Give a very brief answer. -8.14e+05. In the year 2004, what is the difference between the Emissions(kt) in East Asia (developing only) and Emissions(kt) in Sub-Saharan Africa (all income levels)?
Provide a short and direct response. 3.63e+06. In the year 2004, what is the difference between the Emissions(kt) in East Asia (developing only) and Emissions(kt) in Portugal?
Keep it short and to the point. 4.14e+06. In the year 2004, what is the difference between the Emissions(kt) of High income and Emissions(kt) of Sub-Saharan Africa (all income levels)?
Make the answer very short. 4.44e+06. In the year 2004, what is the difference between the Emissions(kt) in High income and Emissions(kt) in Portugal?
Give a very brief answer. 4.95e+06. In the year 2004, what is the difference between the Emissions(kt) of Sub-Saharan Africa (all income levels) and Emissions(kt) of Portugal?
Provide a succinct answer. 5.10e+05. In the year 2005, what is the difference between the Emissions(kt) in East Asia (developing only) and Emissions(kt) in High income?
Your response must be concise. -3.37e+05. In the year 2005, what is the difference between the Emissions(kt) in East Asia (developing only) and Emissions(kt) in Sub-Saharan Africa (all income levels)?
Offer a very short reply. 4.08e+06. In the year 2005, what is the difference between the Emissions(kt) of East Asia (developing only) and Emissions(kt) of Portugal?
Your answer should be compact. 4.58e+06. In the year 2005, what is the difference between the Emissions(kt) in High income and Emissions(kt) in Sub-Saharan Africa (all income levels)?
Keep it short and to the point. 4.42e+06. In the year 2005, what is the difference between the Emissions(kt) in High income and Emissions(kt) in Portugal?
Provide a succinct answer. 4.92e+06. In the year 2005, what is the difference between the Emissions(kt) in Sub-Saharan Africa (all income levels) and Emissions(kt) in Portugal?
Give a very brief answer. 5.02e+05. What is the ratio of the Emissions(kt) of East Asia (developing only) in 1998 to that in 1999?
Your answer should be very brief. 1.02. What is the ratio of the Emissions(kt) of Sub-Saharan Africa (all income levels) in 1998 to that in 1999?
Give a very brief answer. 0.96. What is the ratio of the Emissions(kt) in Portugal in 1998 to that in 1999?
Make the answer very short. 0.82. What is the ratio of the Emissions(kt) in Sub-Saharan Africa (all income levels) in 1998 to that in 2000?
Provide a succinct answer. 0.98. What is the ratio of the Emissions(kt) in Portugal in 1998 to that in 2000?
Give a very brief answer. 0.82. What is the ratio of the Emissions(kt) of East Asia (developing only) in 1998 to that in 2001?
Give a very brief answer. 0.98. What is the ratio of the Emissions(kt) of High income in 1998 to that in 2001?
Provide a succinct answer. 0.96. What is the ratio of the Emissions(kt) of Sub-Saharan Africa (all income levels) in 1998 to that in 2001?
Make the answer very short. 0.98. What is the ratio of the Emissions(kt) of Portugal in 1998 to that in 2001?
Your answer should be compact. 0.97. What is the ratio of the Emissions(kt) in East Asia (developing only) in 1998 to that in 2002?
Offer a terse response. 0.93. What is the ratio of the Emissions(kt) in High income in 1998 to that in 2002?
Make the answer very short. 0.95. What is the ratio of the Emissions(kt) of Sub-Saharan Africa (all income levels) in 1998 to that in 2002?
Give a very brief answer. 1.01. What is the ratio of the Emissions(kt) in Portugal in 1998 to that in 2002?
Your answer should be very brief. 0.89. What is the ratio of the Emissions(kt) in East Asia (developing only) in 1998 to that in 2003?
Ensure brevity in your answer.  0.74. What is the ratio of the Emissions(kt) of High income in 1998 to that in 2003?
Your answer should be compact. 0.94. What is the ratio of the Emissions(kt) in Portugal in 1998 to that in 2003?
Your answer should be compact. 0.95. What is the ratio of the Emissions(kt) of East Asia (developing only) in 1998 to that in 2004?
Give a very brief answer. 0.63. What is the ratio of the Emissions(kt) in High income in 1998 to that in 2004?
Offer a terse response. 0.93. What is the ratio of the Emissions(kt) of Sub-Saharan Africa (all income levels) in 1998 to that in 2004?
Your answer should be compact. 0.9. What is the ratio of the Emissions(kt) in Portugal in 1998 to that in 2004?
Your answer should be compact. 0.91. What is the ratio of the Emissions(kt) of East Asia (developing only) in 1998 to that in 2005?
Your response must be concise. 0.57. What is the ratio of the Emissions(kt) in High income in 1998 to that in 2005?
Ensure brevity in your answer.  0.93. What is the ratio of the Emissions(kt) in Sub-Saharan Africa (all income levels) in 1998 to that in 2005?
Give a very brief answer. 0.92. What is the ratio of the Emissions(kt) of Portugal in 1998 to that in 2005?
Ensure brevity in your answer.  0.92. What is the ratio of the Emissions(kt) of High income in 1999 to that in 2000?
Keep it short and to the point. 0.96. What is the ratio of the Emissions(kt) in East Asia (developing only) in 1999 to that in 2001?
Keep it short and to the point. 0.96. What is the ratio of the Emissions(kt) of High income in 1999 to that in 2001?
Make the answer very short. 0.96. What is the ratio of the Emissions(kt) of Sub-Saharan Africa (all income levels) in 1999 to that in 2001?
Keep it short and to the point. 1.01. What is the ratio of the Emissions(kt) in Portugal in 1999 to that in 2001?
Provide a succinct answer. 1.18. What is the ratio of the Emissions(kt) in East Asia (developing only) in 1999 to that in 2002?
Offer a very short reply. 0.91. What is the ratio of the Emissions(kt) of High income in 1999 to that in 2002?
Your answer should be compact. 0.96. What is the ratio of the Emissions(kt) in Sub-Saharan Africa (all income levels) in 1999 to that in 2002?
Give a very brief answer. 1.05. What is the ratio of the Emissions(kt) in Portugal in 1999 to that in 2002?
Make the answer very short. 1.09. What is the ratio of the Emissions(kt) of East Asia (developing only) in 1999 to that in 2003?
Your response must be concise. 0.73. What is the ratio of the Emissions(kt) of High income in 1999 to that in 2003?
Keep it short and to the point. 0.95. What is the ratio of the Emissions(kt) in Portugal in 1999 to that in 2003?
Provide a succinct answer. 1.16. What is the ratio of the Emissions(kt) in East Asia (developing only) in 1999 to that in 2004?
Your answer should be very brief. 0.62. What is the ratio of the Emissions(kt) in High income in 1999 to that in 2004?
Give a very brief answer. 0.93. What is the ratio of the Emissions(kt) of Sub-Saharan Africa (all income levels) in 1999 to that in 2004?
Provide a short and direct response. 0.93. What is the ratio of the Emissions(kt) in Portugal in 1999 to that in 2004?
Provide a succinct answer. 1.12. What is the ratio of the Emissions(kt) of East Asia (developing only) in 1999 to that in 2005?
Your answer should be very brief. 0.56. What is the ratio of the Emissions(kt) of High income in 1999 to that in 2005?
Make the answer very short. 0.94. What is the ratio of the Emissions(kt) of Sub-Saharan Africa (all income levels) in 1999 to that in 2005?
Provide a succinct answer. 0.95. What is the ratio of the Emissions(kt) in Portugal in 1999 to that in 2005?
Make the answer very short. 1.13. What is the ratio of the Emissions(kt) of East Asia (developing only) in 2000 to that in 2001?
Provide a succinct answer. 0.98. What is the ratio of the Emissions(kt) in Portugal in 2000 to that in 2001?
Provide a succinct answer. 1.18. What is the ratio of the Emissions(kt) of East Asia (developing only) in 2000 to that in 2002?
Make the answer very short. 0.93. What is the ratio of the Emissions(kt) in Sub-Saharan Africa (all income levels) in 2000 to that in 2002?
Give a very brief answer. 1.04. What is the ratio of the Emissions(kt) of Portugal in 2000 to that in 2002?
Give a very brief answer. 1.09. What is the ratio of the Emissions(kt) in East Asia (developing only) in 2000 to that in 2003?
Your answer should be very brief. 0.74. What is the ratio of the Emissions(kt) of Portugal in 2000 to that in 2003?
Offer a very short reply. 1.15. What is the ratio of the Emissions(kt) of East Asia (developing only) in 2000 to that in 2004?
Offer a very short reply. 0.63. What is the ratio of the Emissions(kt) in High income in 2000 to that in 2004?
Offer a terse response. 0.97. What is the ratio of the Emissions(kt) in Sub-Saharan Africa (all income levels) in 2000 to that in 2004?
Provide a succinct answer. 0.92. What is the ratio of the Emissions(kt) in Portugal in 2000 to that in 2004?
Provide a succinct answer. 1.11. What is the ratio of the Emissions(kt) in East Asia (developing only) in 2000 to that in 2005?
Your answer should be compact. 0.57. What is the ratio of the Emissions(kt) of High income in 2000 to that in 2005?
Provide a succinct answer. 0.98. What is the ratio of the Emissions(kt) in Sub-Saharan Africa (all income levels) in 2000 to that in 2005?
Keep it short and to the point. 0.94. What is the ratio of the Emissions(kt) of Portugal in 2000 to that in 2005?
Your response must be concise. 1.12. What is the ratio of the Emissions(kt) in East Asia (developing only) in 2001 to that in 2002?
Your response must be concise. 0.95. What is the ratio of the Emissions(kt) of Sub-Saharan Africa (all income levels) in 2001 to that in 2002?
Provide a succinct answer. 1.04. What is the ratio of the Emissions(kt) in Portugal in 2001 to that in 2002?
Ensure brevity in your answer.  0.92. What is the ratio of the Emissions(kt) of East Asia (developing only) in 2001 to that in 2003?
Your answer should be very brief. 0.76. What is the ratio of the Emissions(kt) in High income in 2001 to that in 2003?
Offer a terse response. 0.98. What is the ratio of the Emissions(kt) of Portugal in 2001 to that in 2003?
Make the answer very short. 0.98. What is the ratio of the Emissions(kt) in East Asia (developing only) in 2001 to that in 2004?
Offer a very short reply. 0.64. What is the ratio of the Emissions(kt) of High income in 2001 to that in 2004?
Offer a very short reply. 0.97. What is the ratio of the Emissions(kt) of Sub-Saharan Africa (all income levels) in 2001 to that in 2004?
Provide a short and direct response. 0.92. What is the ratio of the Emissions(kt) in Portugal in 2001 to that in 2004?
Provide a succinct answer. 0.95. What is the ratio of the Emissions(kt) in East Asia (developing only) in 2001 to that in 2005?
Your response must be concise. 0.58. What is the ratio of the Emissions(kt) of High income in 2001 to that in 2005?
Your answer should be compact. 0.97. What is the ratio of the Emissions(kt) of Sub-Saharan Africa (all income levels) in 2001 to that in 2005?
Your response must be concise. 0.94. What is the ratio of the Emissions(kt) in Portugal in 2001 to that in 2005?
Your response must be concise. 0.95. What is the ratio of the Emissions(kt) in East Asia (developing only) in 2002 to that in 2003?
Keep it short and to the point. 0.8. What is the ratio of the Emissions(kt) of High income in 2002 to that in 2003?
Offer a terse response. 0.99. What is the ratio of the Emissions(kt) in Sub-Saharan Africa (all income levels) in 2002 to that in 2003?
Provide a succinct answer. 0.95. What is the ratio of the Emissions(kt) of Portugal in 2002 to that in 2003?
Ensure brevity in your answer.  1.06. What is the ratio of the Emissions(kt) in East Asia (developing only) in 2002 to that in 2004?
Your answer should be compact. 0.68. What is the ratio of the Emissions(kt) in High income in 2002 to that in 2004?
Provide a succinct answer. 0.97. What is the ratio of the Emissions(kt) in Sub-Saharan Africa (all income levels) in 2002 to that in 2004?
Make the answer very short. 0.89. What is the ratio of the Emissions(kt) of Portugal in 2002 to that in 2004?
Keep it short and to the point. 1.02. What is the ratio of the Emissions(kt) in East Asia (developing only) in 2002 to that in 2005?
Provide a short and direct response. 0.61. What is the ratio of the Emissions(kt) of High income in 2002 to that in 2005?
Keep it short and to the point. 0.98. What is the ratio of the Emissions(kt) of Sub-Saharan Africa (all income levels) in 2002 to that in 2005?
Make the answer very short. 0.91. What is the ratio of the Emissions(kt) in Portugal in 2002 to that in 2005?
Provide a succinct answer. 1.03. What is the ratio of the Emissions(kt) in East Asia (developing only) in 2003 to that in 2004?
Your answer should be compact. 0.85. What is the ratio of the Emissions(kt) in High income in 2003 to that in 2004?
Offer a terse response. 0.98. What is the ratio of the Emissions(kt) in Sub-Saharan Africa (all income levels) in 2003 to that in 2004?
Keep it short and to the point. 0.93. What is the ratio of the Emissions(kt) in Portugal in 2003 to that in 2004?
Offer a very short reply. 0.97. What is the ratio of the Emissions(kt) in East Asia (developing only) in 2003 to that in 2005?
Your answer should be very brief. 0.77. What is the ratio of the Emissions(kt) in High income in 2003 to that in 2005?
Provide a short and direct response. 0.99. What is the ratio of the Emissions(kt) of Sub-Saharan Africa (all income levels) in 2003 to that in 2005?
Provide a short and direct response. 0.95. What is the ratio of the Emissions(kt) in Portugal in 2003 to that in 2005?
Provide a short and direct response. 0.97. What is the ratio of the Emissions(kt) in East Asia (developing only) in 2004 to that in 2005?
Make the answer very short. 0.9. What is the ratio of the Emissions(kt) in High income in 2004 to that in 2005?
Your answer should be very brief. 1.01. What is the ratio of the Emissions(kt) of Sub-Saharan Africa (all income levels) in 2004 to that in 2005?
Give a very brief answer. 1.02. What is the ratio of the Emissions(kt) in Portugal in 2004 to that in 2005?
Keep it short and to the point. 1.01. What is the difference between the highest and the second highest Emissions(kt) in East Asia (developing only)?
Offer a terse response. 4.45e+05. What is the difference between the highest and the second highest Emissions(kt) of High income?
Offer a terse response. 3.20e+04. What is the difference between the highest and the second highest Emissions(kt) of Sub-Saharan Africa (all income levels)?
Offer a very short reply. 8467.34. What is the difference between the highest and the second highest Emissions(kt) in Portugal?
Your answer should be compact. 25.67. What is the difference between the highest and the lowest Emissions(kt) of East Asia (developing only)?
Keep it short and to the point. 2.02e+06. What is the difference between the highest and the lowest Emissions(kt) in High income?
Give a very brief answer. 3.53e+05. What is the difference between the highest and the lowest Emissions(kt) of Sub-Saharan Africa (all income levels)?
Your answer should be very brief. 5.70e+04. What is the difference between the highest and the lowest Emissions(kt) in Portugal?
Provide a short and direct response. 2603.57. 